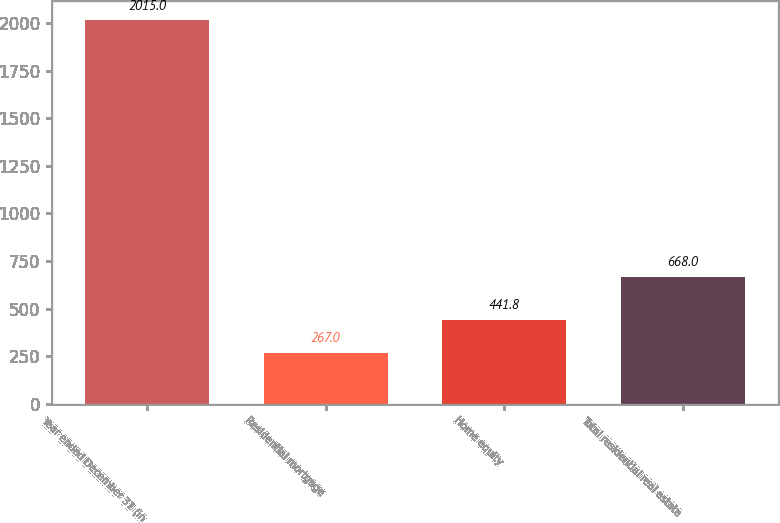<chart> <loc_0><loc_0><loc_500><loc_500><bar_chart><fcel>Year ended December 31 (in<fcel>Residential mortgage<fcel>Home equity<fcel>Total residential real estate<nl><fcel>2015<fcel>267<fcel>441.8<fcel>668<nl></chart> 